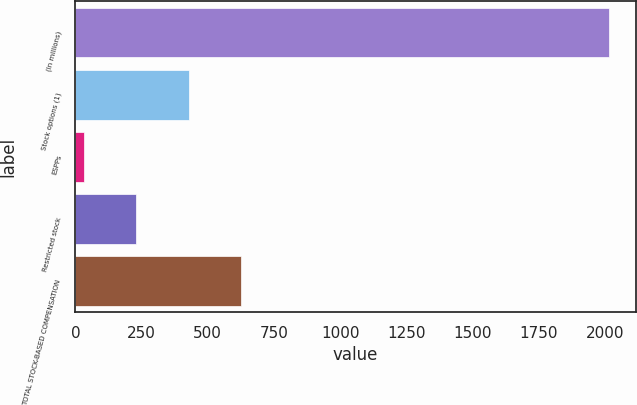Convert chart to OTSL. <chart><loc_0><loc_0><loc_500><loc_500><bar_chart><fcel>(In millions)<fcel>Stock options (1)<fcel>ESPPs<fcel>Restricted stock<fcel>TOTAL STOCK-BASED COMPENSATION<nl><fcel>2016<fcel>428<fcel>31<fcel>229.5<fcel>626.5<nl></chart> 